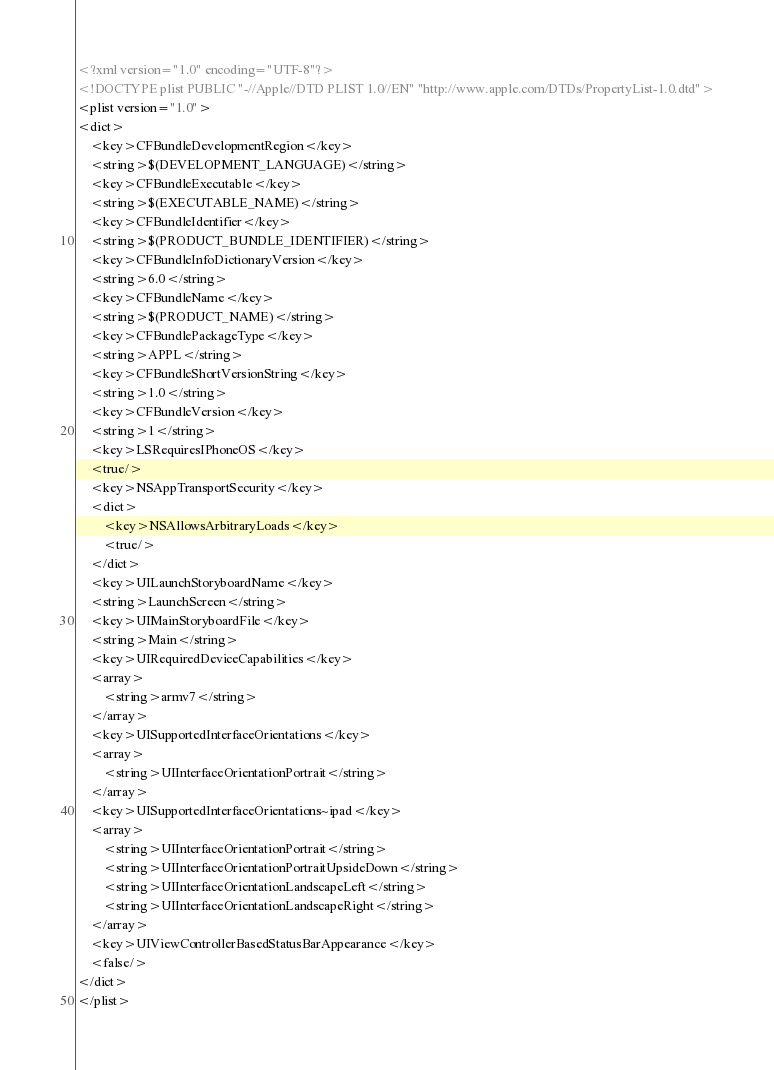<code> <loc_0><loc_0><loc_500><loc_500><_XML_><?xml version="1.0" encoding="UTF-8"?>
<!DOCTYPE plist PUBLIC "-//Apple//DTD PLIST 1.0//EN" "http://www.apple.com/DTDs/PropertyList-1.0.dtd">
<plist version="1.0">
<dict>
	<key>CFBundleDevelopmentRegion</key>
	<string>$(DEVELOPMENT_LANGUAGE)</string>
	<key>CFBundleExecutable</key>
	<string>$(EXECUTABLE_NAME)</string>
	<key>CFBundleIdentifier</key>
	<string>$(PRODUCT_BUNDLE_IDENTIFIER)</string>
	<key>CFBundleInfoDictionaryVersion</key>
	<string>6.0</string>
	<key>CFBundleName</key>
	<string>$(PRODUCT_NAME)</string>
	<key>CFBundlePackageType</key>
	<string>APPL</string>
	<key>CFBundleShortVersionString</key>
	<string>1.0</string>
	<key>CFBundleVersion</key>
	<string>1</string>
	<key>LSRequiresIPhoneOS</key>
	<true/>
	<key>NSAppTransportSecurity</key>
	<dict>
		<key>NSAllowsArbitraryLoads</key>
		<true/>
	</dict>
	<key>UILaunchStoryboardName</key>
	<string>LaunchScreen</string>
	<key>UIMainStoryboardFile</key>
	<string>Main</string>
	<key>UIRequiredDeviceCapabilities</key>
	<array>
		<string>armv7</string>
	</array>
	<key>UISupportedInterfaceOrientations</key>
	<array>
		<string>UIInterfaceOrientationPortrait</string>
	</array>
	<key>UISupportedInterfaceOrientations~ipad</key>
	<array>
		<string>UIInterfaceOrientationPortrait</string>
		<string>UIInterfaceOrientationPortraitUpsideDown</string>
		<string>UIInterfaceOrientationLandscapeLeft</string>
		<string>UIInterfaceOrientationLandscapeRight</string>
	</array>
	<key>UIViewControllerBasedStatusBarAppearance</key>
	<false/>
</dict>
</plist>
</code> 